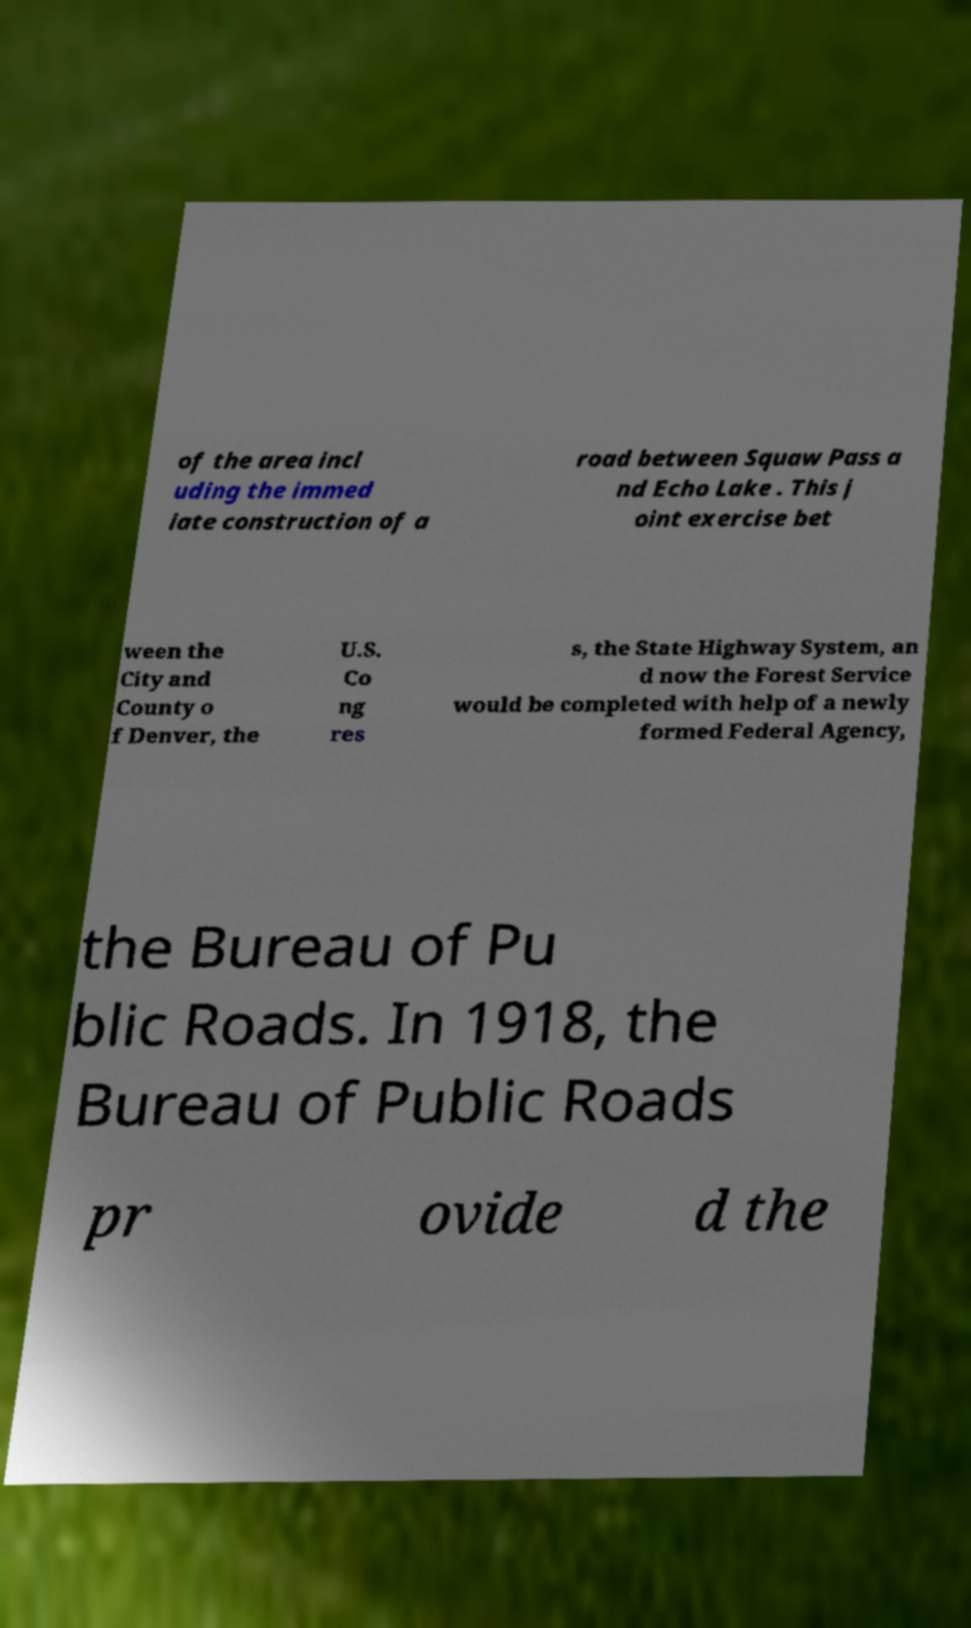Can you accurately transcribe the text from the provided image for me? of the area incl uding the immed iate construction of a road between Squaw Pass a nd Echo Lake . This j oint exercise bet ween the City and County o f Denver, the U.S. Co ng res s, the State Highway System, an d now the Forest Service would be completed with help of a newly formed Federal Agency, the Bureau of Pu blic Roads. In 1918, the Bureau of Public Roads pr ovide d the 